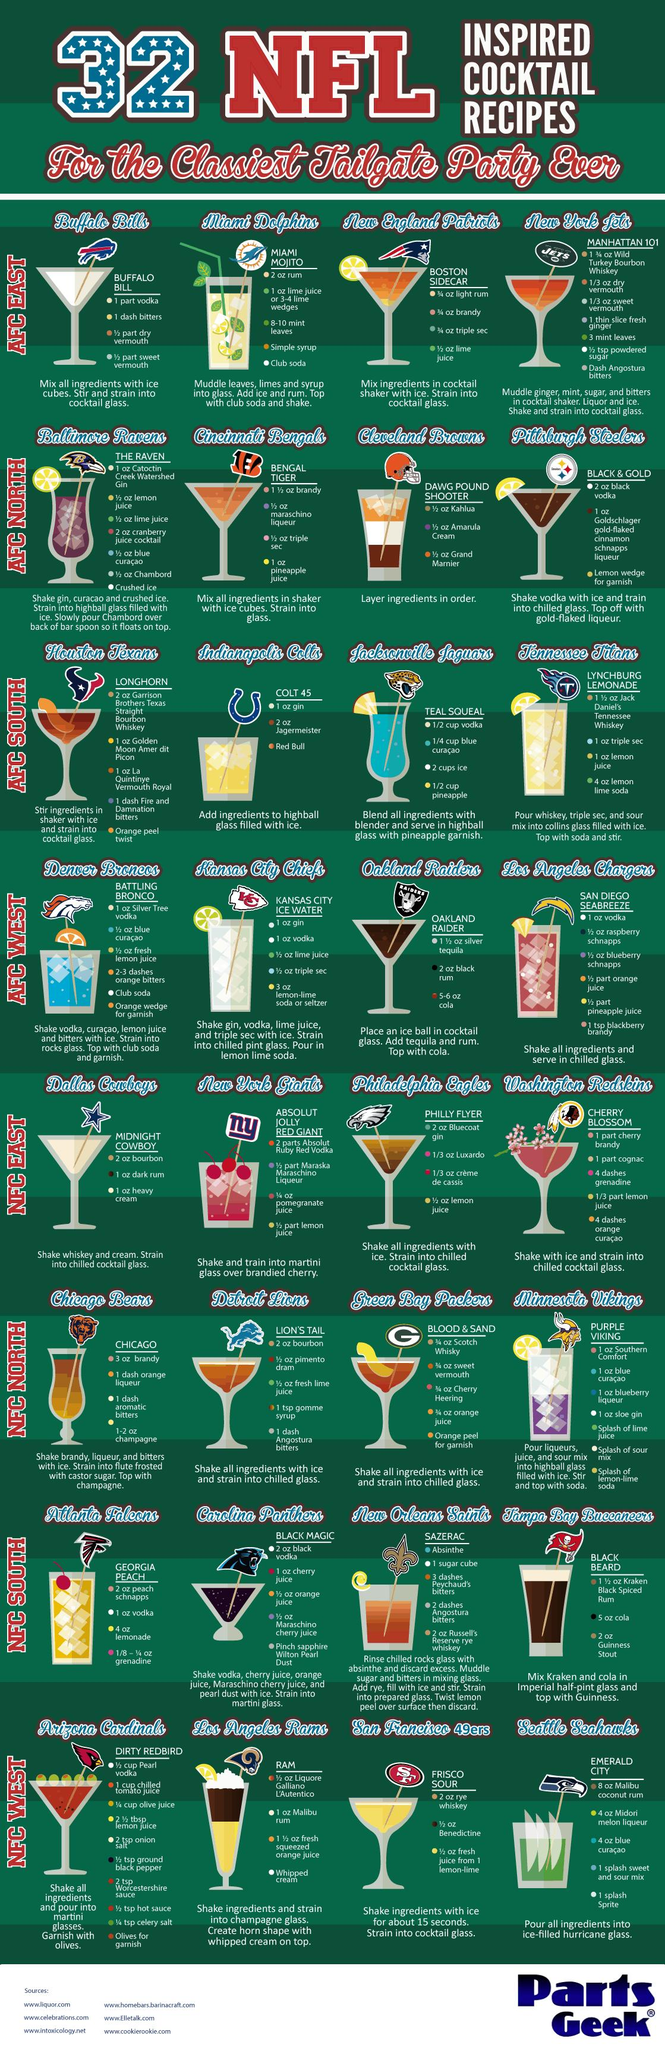Draw attention to some important aspects in this diagram. The cocktail with an image of a panther is named Black Magic. The American Football Confederation (AFC) is divided into four zones. I am a recipe with a cocktail stick that has a blue hawk, known as the "Emerald City" recipe. The Bengal Tiger cocktail recipe from the AFC North contains pineapple juice. The Arizona Cardinals possess the recipe for the prized "dirty red bird" dish. 